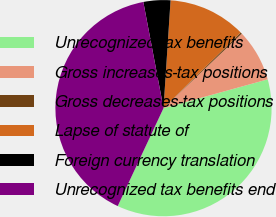<chart> <loc_0><loc_0><loc_500><loc_500><pie_chart><fcel>Unrecognized tax benefits<fcel>Gross increases-tax positions<fcel>Gross decreases-tax positions<fcel>Lapse of statute of<fcel>Foreign currency translation<fcel>Unrecognized tax benefits end<nl><fcel>36.26%<fcel>7.82%<fcel>0.24%<fcel>11.61%<fcel>4.03%<fcel>40.05%<nl></chart> 